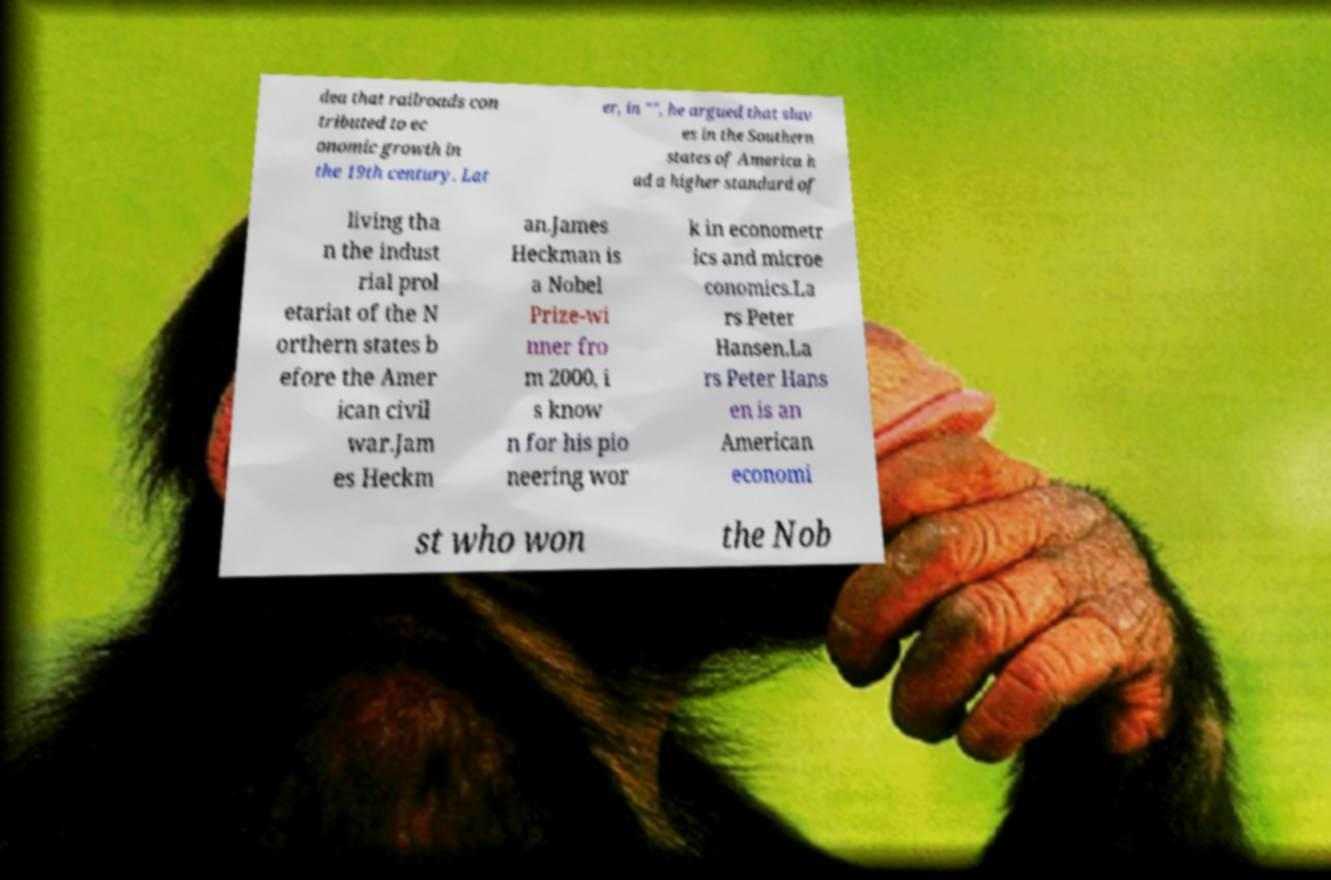Could you extract and type out the text from this image? dea that railroads con tributed to ec onomic growth in the 19th century. Lat er, in "", he argued that slav es in the Southern states of America h ad a higher standard of living tha n the indust rial prol etariat of the N orthern states b efore the Amer ican civil war.Jam es Heckm an.James Heckman is a Nobel Prize-wi nner fro m 2000, i s know n for his pio neering wor k in econometr ics and microe conomics.La rs Peter Hansen.La rs Peter Hans en is an American economi st who won the Nob 